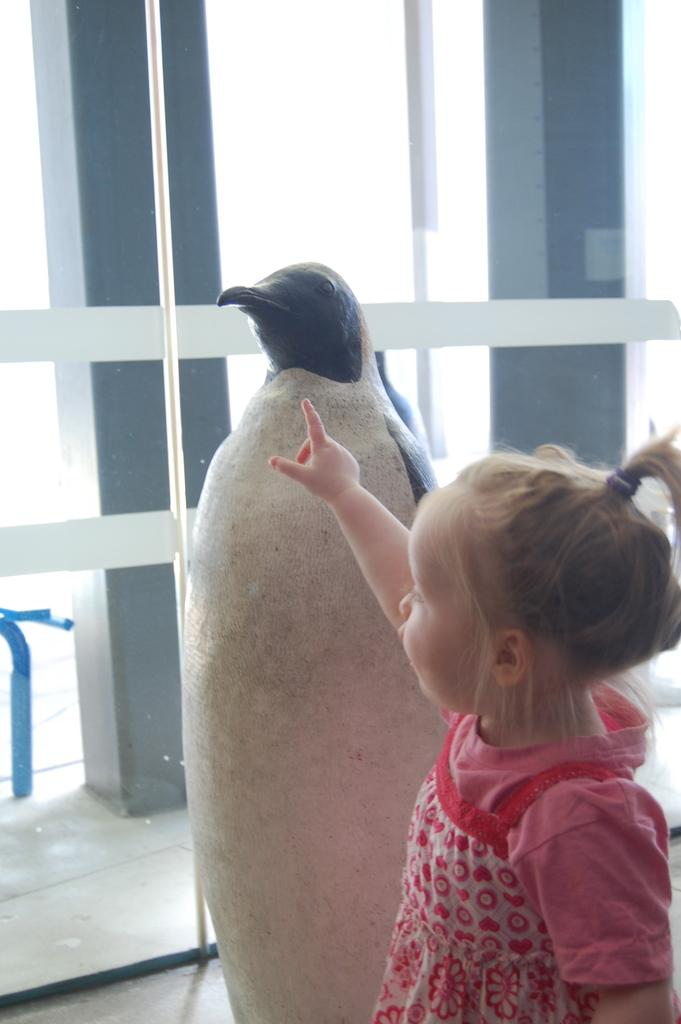What is the main subject of the image? There is a small girl standing in the image. Are there any other objects or structures in the image? Yes, there is a statue in the image. What type of bread is the girl holding in the image? There is no bread present in the image. What tools might the carpenter be using to build the statue in the image? There is no carpenter or tools visible in the image; it only shows a small girl and a statue. 